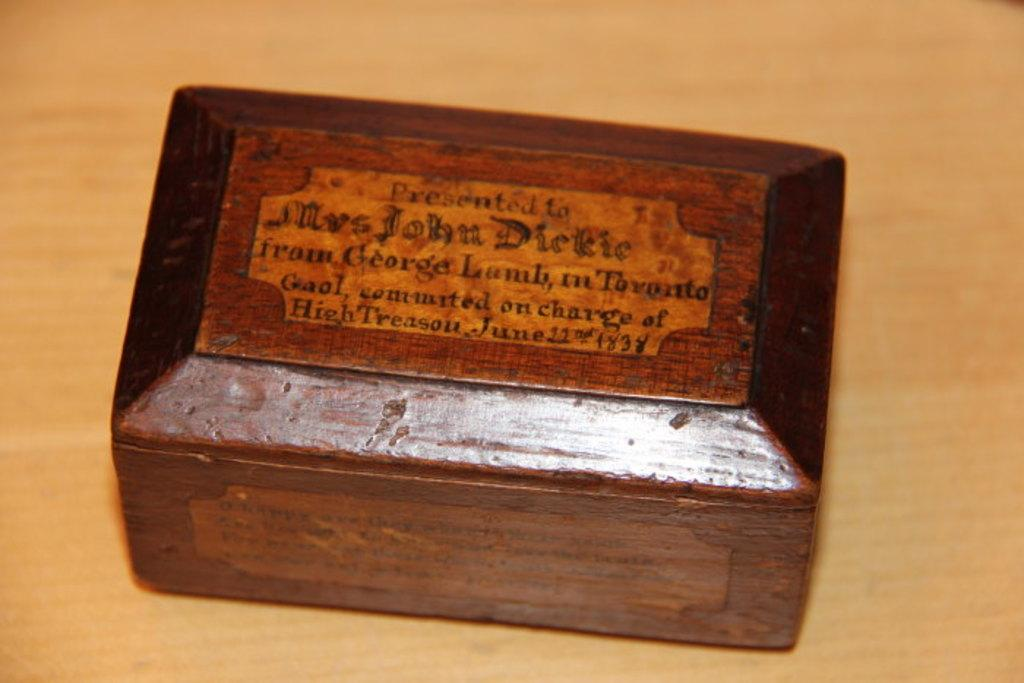<image>
Write a terse but informative summary of the picture. An antique wooden box has enscripted on the top "presented to Mrs John Dickie" 